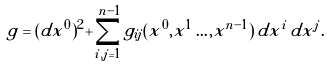<formula> <loc_0><loc_0><loc_500><loc_500>g = ( d x ^ { 0 } ) ^ { 2 } + \sum _ { i , j = 1 } ^ { n - 1 } g _ { i j } ( x ^ { 0 } , x ^ { 1 } \dots , x ^ { n - 1 } ) \, d x ^ { i } \, d x ^ { j } .</formula> 